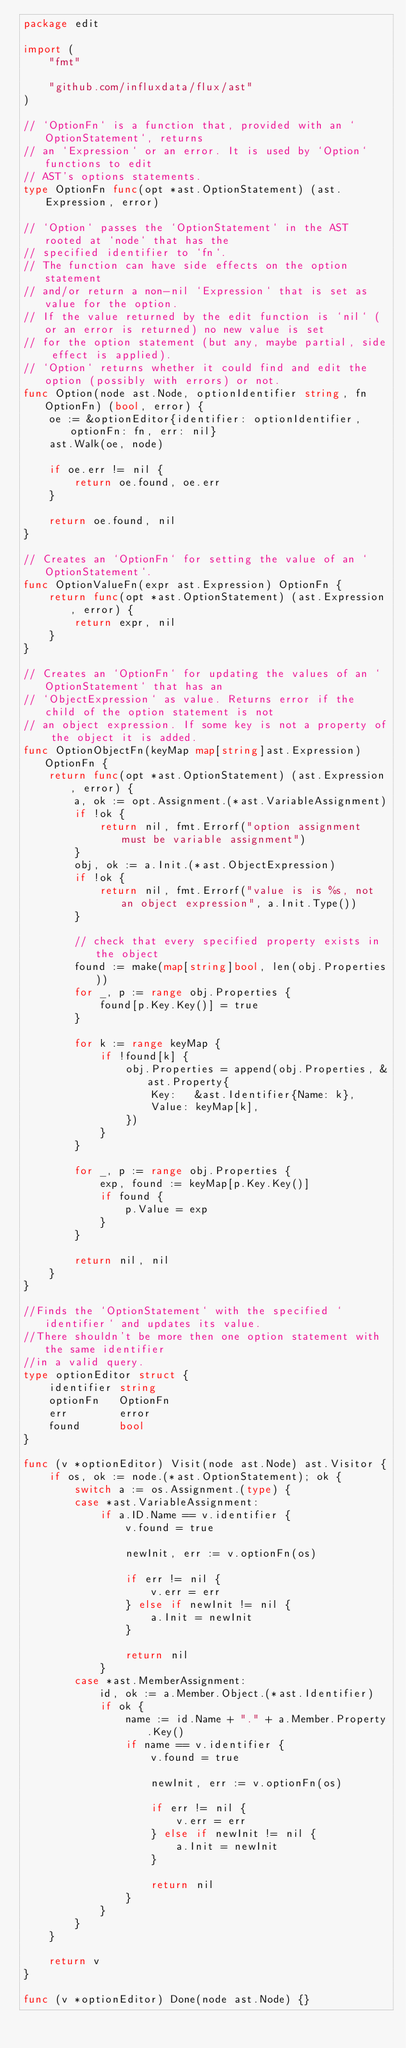<code> <loc_0><loc_0><loc_500><loc_500><_Go_>package edit

import (
	"fmt"

	"github.com/influxdata/flux/ast"
)

// `OptionFn` is a function that, provided with an `OptionStatement`, returns
// an `Expression` or an error. It is used by `Option` functions to edit
// AST's options statements.
type OptionFn func(opt *ast.OptionStatement) (ast.Expression, error)

// `Option` passes the `OptionStatement` in the AST rooted at `node` that has the
// specified identifier to `fn`.
// The function can have side effects on the option statement
// and/or return a non-nil `Expression` that is set as value for the option.
// If the value returned by the edit function is `nil` (or an error is returned) no new value is set
// for the option statement (but any, maybe partial, side effect is applied).
// `Option` returns whether it could find and edit the option (possibly with errors) or not.
func Option(node ast.Node, optionIdentifier string, fn OptionFn) (bool, error) {
	oe := &optionEditor{identifier: optionIdentifier, optionFn: fn, err: nil}
	ast.Walk(oe, node)

	if oe.err != nil {
		return oe.found, oe.err
	}

	return oe.found, nil
}

// Creates an `OptionFn` for setting the value of an `OptionStatement`.
func OptionValueFn(expr ast.Expression) OptionFn {
	return func(opt *ast.OptionStatement) (ast.Expression, error) {
		return expr, nil
	}
}

// Creates an `OptionFn` for updating the values of an `OptionStatement` that has an
// `ObjectExpression` as value. Returns error if the child of the option statement is not
// an object expression. If some key is not a property of the object it is added.
func OptionObjectFn(keyMap map[string]ast.Expression) OptionFn {
	return func(opt *ast.OptionStatement) (ast.Expression, error) {
		a, ok := opt.Assignment.(*ast.VariableAssignment)
		if !ok {
			return nil, fmt.Errorf("option assignment must be variable assignment")
		}
		obj, ok := a.Init.(*ast.ObjectExpression)
		if !ok {
			return nil, fmt.Errorf("value is is %s, not an object expression", a.Init.Type())
		}

		// check that every specified property exists in the object
		found := make(map[string]bool, len(obj.Properties))
		for _, p := range obj.Properties {
			found[p.Key.Key()] = true
		}

		for k := range keyMap {
			if !found[k] {
				obj.Properties = append(obj.Properties, &ast.Property{
					Key:   &ast.Identifier{Name: k},
					Value: keyMap[k],
				})
			}
		}

		for _, p := range obj.Properties {
			exp, found := keyMap[p.Key.Key()]
			if found {
				p.Value = exp
			}
		}

		return nil, nil
	}
}

//Finds the `OptionStatement` with the specified `identifier` and updates its value.
//There shouldn't be more then one option statement with the same identifier
//in a valid query.
type optionEditor struct {
	identifier string
	optionFn   OptionFn
	err        error
	found      bool
}

func (v *optionEditor) Visit(node ast.Node) ast.Visitor {
	if os, ok := node.(*ast.OptionStatement); ok {
		switch a := os.Assignment.(type) {
		case *ast.VariableAssignment:
			if a.ID.Name == v.identifier {
				v.found = true

				newInit, err := v.optionFn(os)

				if err != nil {
					v.err = err
				} else if newInit != nil {
					a.Init = newInit
				}

				return nil
			}
		case *ast.MemberAssignment:
			id, ok := a.Member.Object.(*ast.Identifier)
			if ok {
				name := id.Name + "." + a.Member.Property.Key()
				if name == v.identifier {
					v.found = true

					newInit, err := v.optionFn(os)

					if err != nil {
						v.err = err
					} else if newInit != nil {
						a.Init = newInit
					}

					return nil
				}
			}
		}
	}

	return v
}

func (v *optionEditor) Done(node ast.Node) {}
</code> 